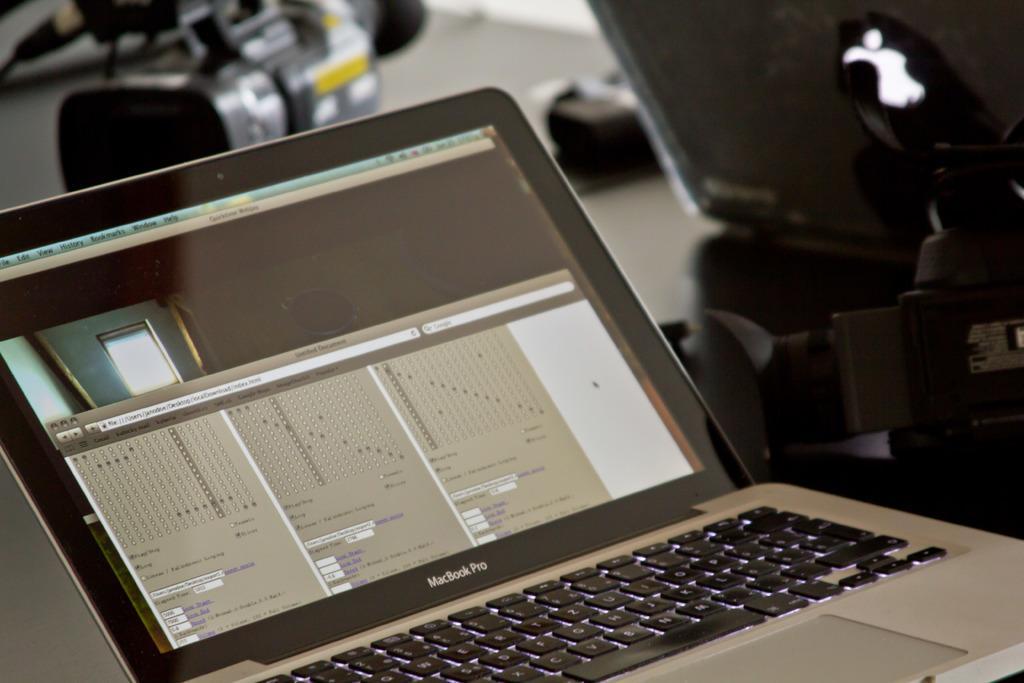Could you give a brief overview of what you see in this image? This image consists of a laptop and a camera. To the right, there is a camera stand. These all are kept on a table. 